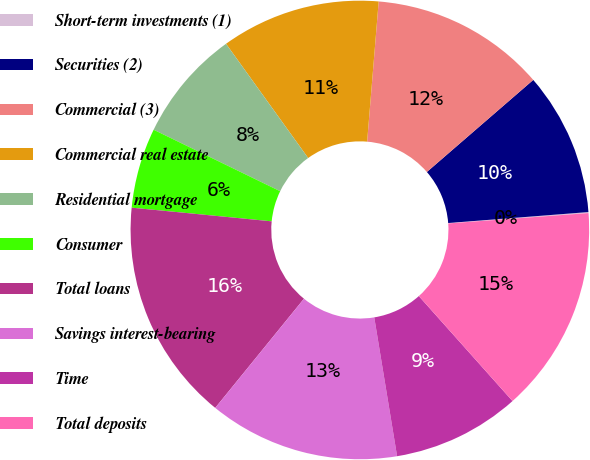<chart> <loc_0><loc_0><loc_500><loc_500><pie_chart><fcel>Short-term investments (1)<fcel>Securities (2)<fcel>Commercial (3)<fcel>Commercial real estate<fcel>Residential mortgage<fcel>Consumer<fcel>Total loans<fcel>Savings interest-bearing<fcel>Time<fcel>Total deposits<nl><fcel>0.07%<fcel>10.11%<fcel>12.34%<fcel>11.23%<fcel>7.88%<fcel>5.65%<fcel>15.69%<fcel>13.46%<fcel>9.0%<fcel>14.58%<nl></chart> 